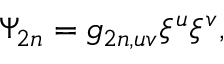<formula> <loc_0><loc_0><loc_500><loc_500>\Psi _ { 2 n } = g _ { 2 n , u v } \xi ^ { u } \xi ^ { v } ,</formula> 